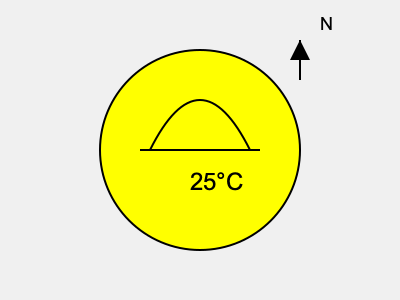Based on the weather symbol shown, which of the following statements is most accurate for kayaking conditions?

A) It's safe to go kayaking without any precautions
B) There's a high risk of thunderstorms, so kayaking should be avoided
C) The conditions are generally favorable, but sun protection is advisable
D) Strong winds are expected, making kayaking dangerous Let's interpret the weather symbol step-by-step:

1. The large yellow circle represents a sunny day with clear skies.

2. The curved line at the top of the circle indicates some high clouds, but not enough to significantly impact the weather.

3. The straight line below represents calm winds or very light breezes.

4. The temperature reading of 25°C (77°F) indicates warm weather.

5. The arrow in the top right corner shows the wind direction (from south to north), but its small size suggests light winds.

Given these interpretations:

- The weather is generally favorable for kayaking.
- There are no indications of storms or strong winds that would make kayaking dangerous.
- The sunny conditions and warm temperature suggest that sun protection would be advisable.
- While the conditions are good, it's always important for kayakers to take basic safety precautions.

Therefore, the most accurate statement for these conditions is that they are generally favorable for kayaking, but sun protection is advisable due to the clear, sunny weather.
Answer: C) The conditions are generally favorable, but sun protection is advisable 